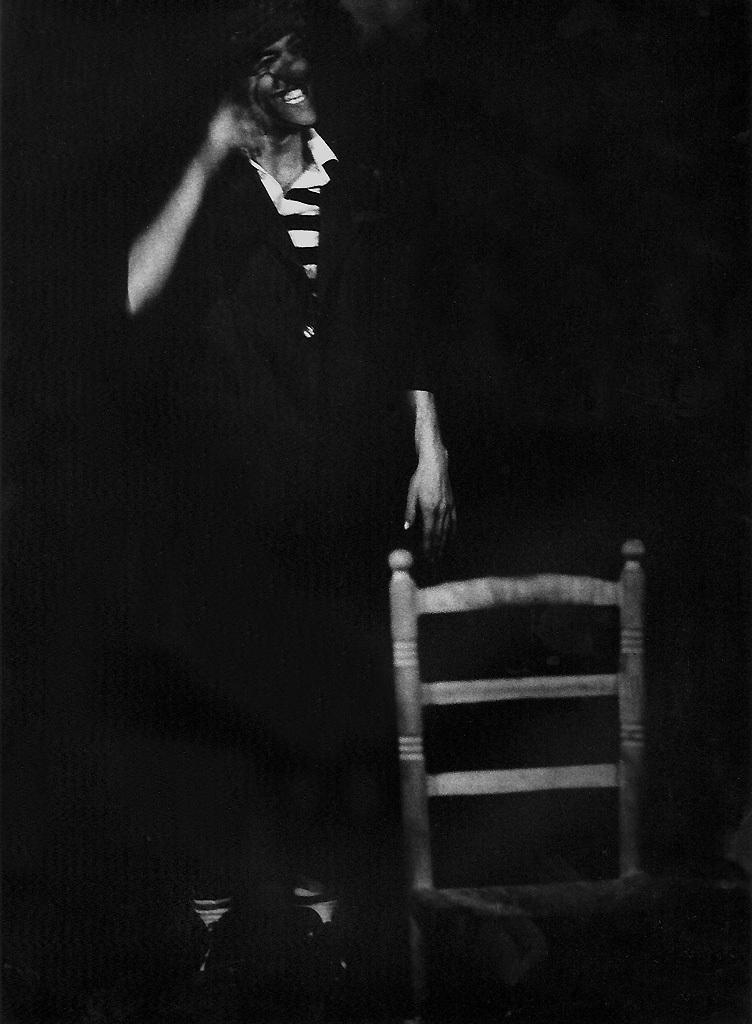Could you give a brief overview of what you see in this image? This is a black and white image. In this image we can see a person and a chair. 